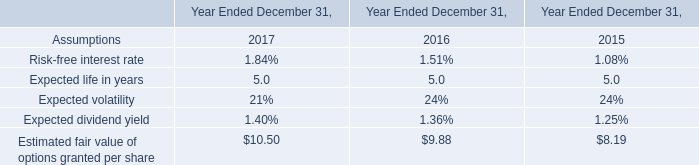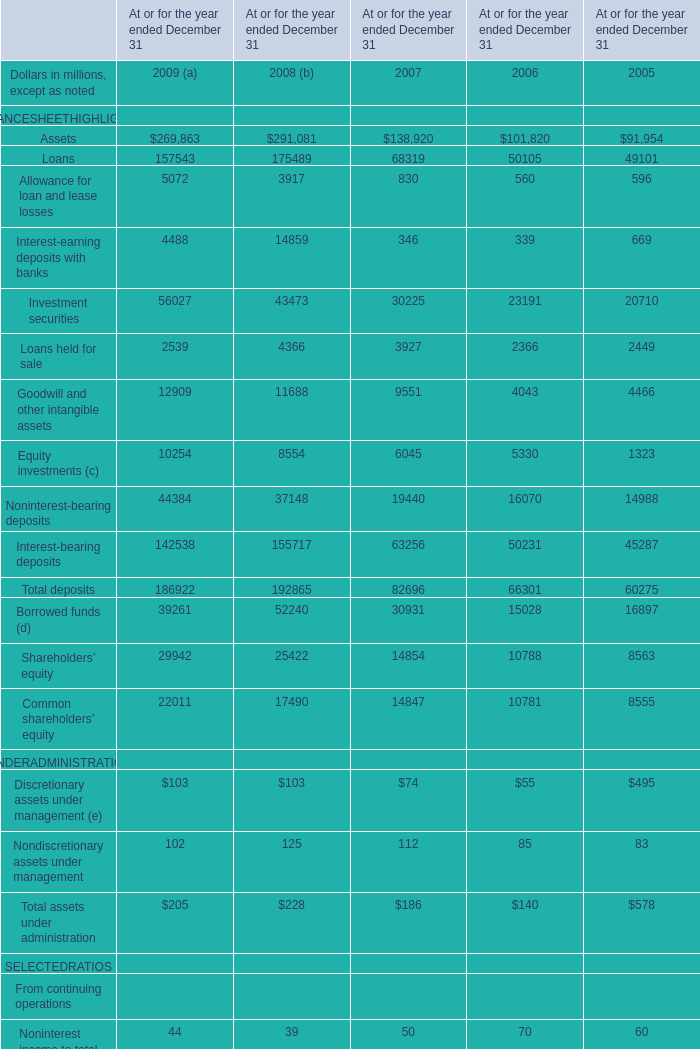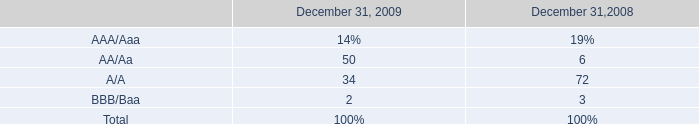What was the average value of Loans held for sale, Goodwill and other intangible assets, Equity investments (c) in 2007? (in million) 
Computations: (((3927 + 9551) + 6045) / 3)
Answer: 6507.66667. 